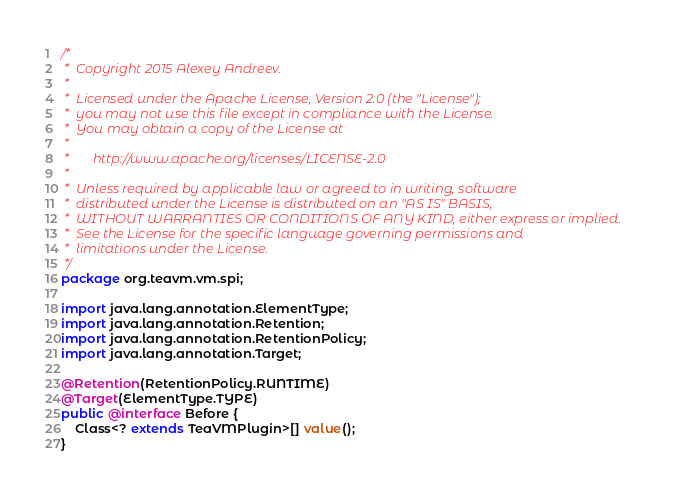Convert code to text. <code><loc_0><loc_0><loc_500><loc_500><_Java_>/*
 *  Copyright 2015 Alexey Andreev.
 *
 *  Licensed under the Apache License, Version 2.0 (the "License");
 *  you may not use this file except in compliance with the License.
 *  You may obtain a copy of the License at
 *
 *       http://www.apache.org/licenses/LICENSE-2.0
 *
 *  Unless required by applicable law or agreed to in writing, software
 *  distributed under the License is distributed on an "AS IS" BASIS,
 *  WITHOUT WARRANTIES OR CONDITIONS OF ANY KIND, either express or implied.
 *  See the License for the specific language governing permissions and
 *  limitations under the License.
 */
package org.teavm.vm.spi;

import java.lang.annotation.ElementType;
import java.lang.annotation.Retention;
import java.lang.annotation.RetentionPolicy;
import java.lang.annotation.Target;

@Retention(RetentionPolicy.RUNTIME)
@Target(ElementType.TYPE)
public @interface Before {
    Class<? extends TeaVMPlugin>[] value();
}
</code> 